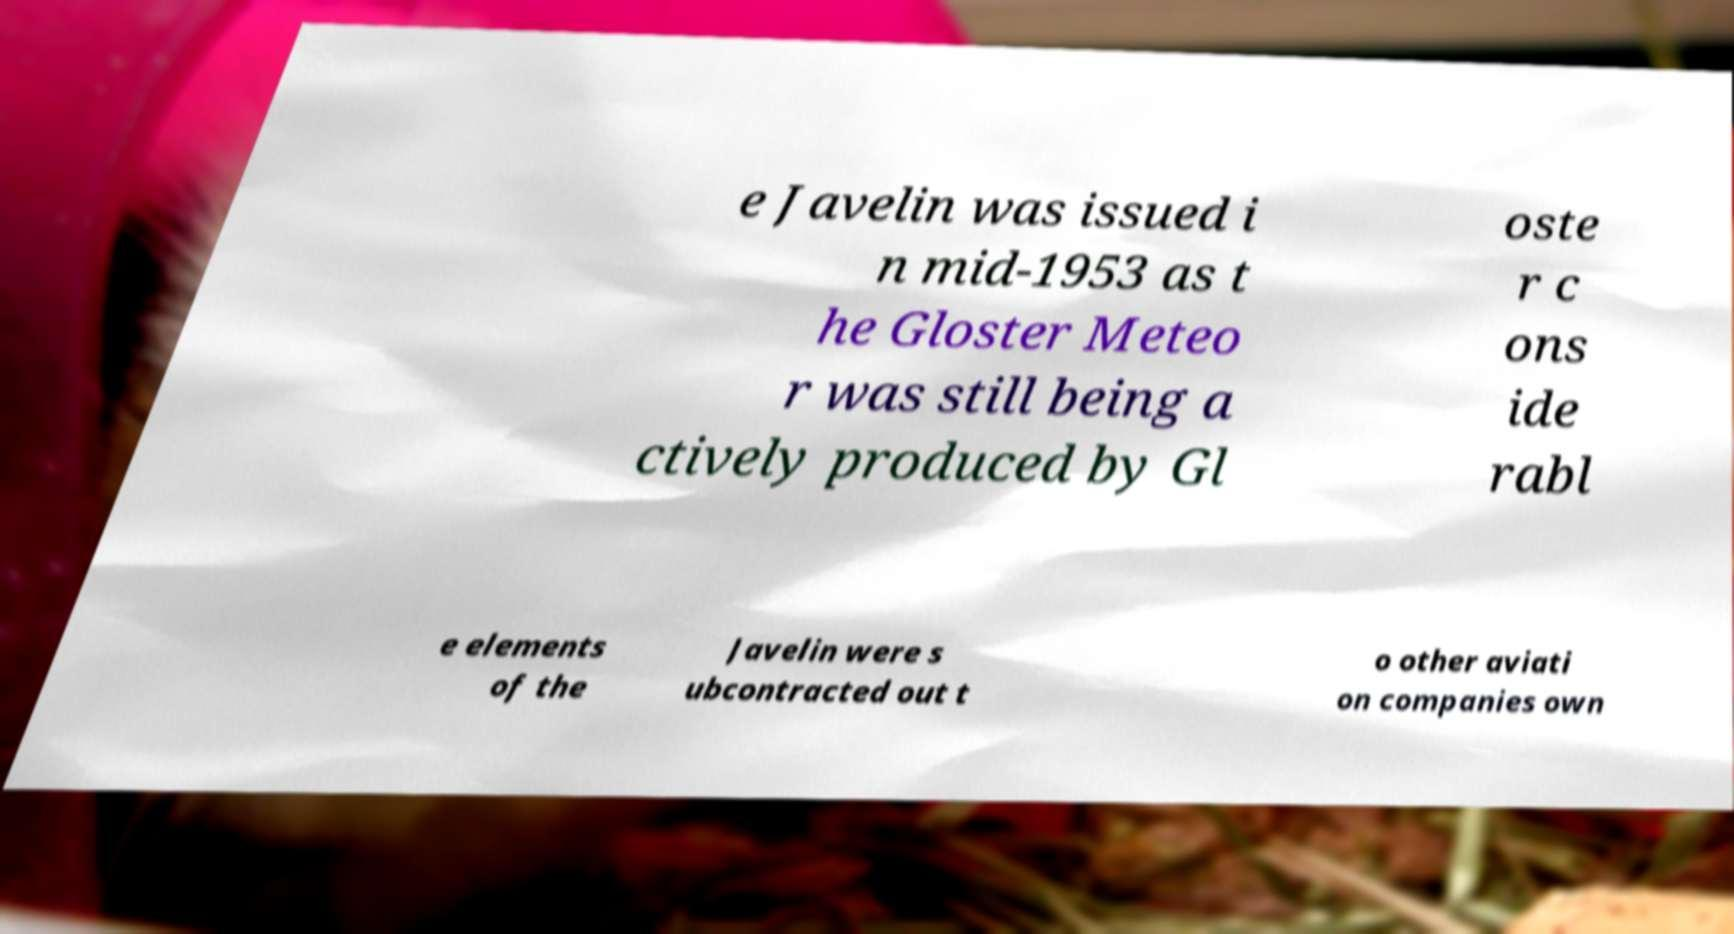There's text embedded in this image that I need extracted. Can you transcribe it verbatim? e Javelin was issued i n mid-1953 as t he Gloster Meteo r was still being a ctively produced by Gl oste r c ons ide rabl e elements of the Javelin were s ubcontracted out t o other aviati on companies own 